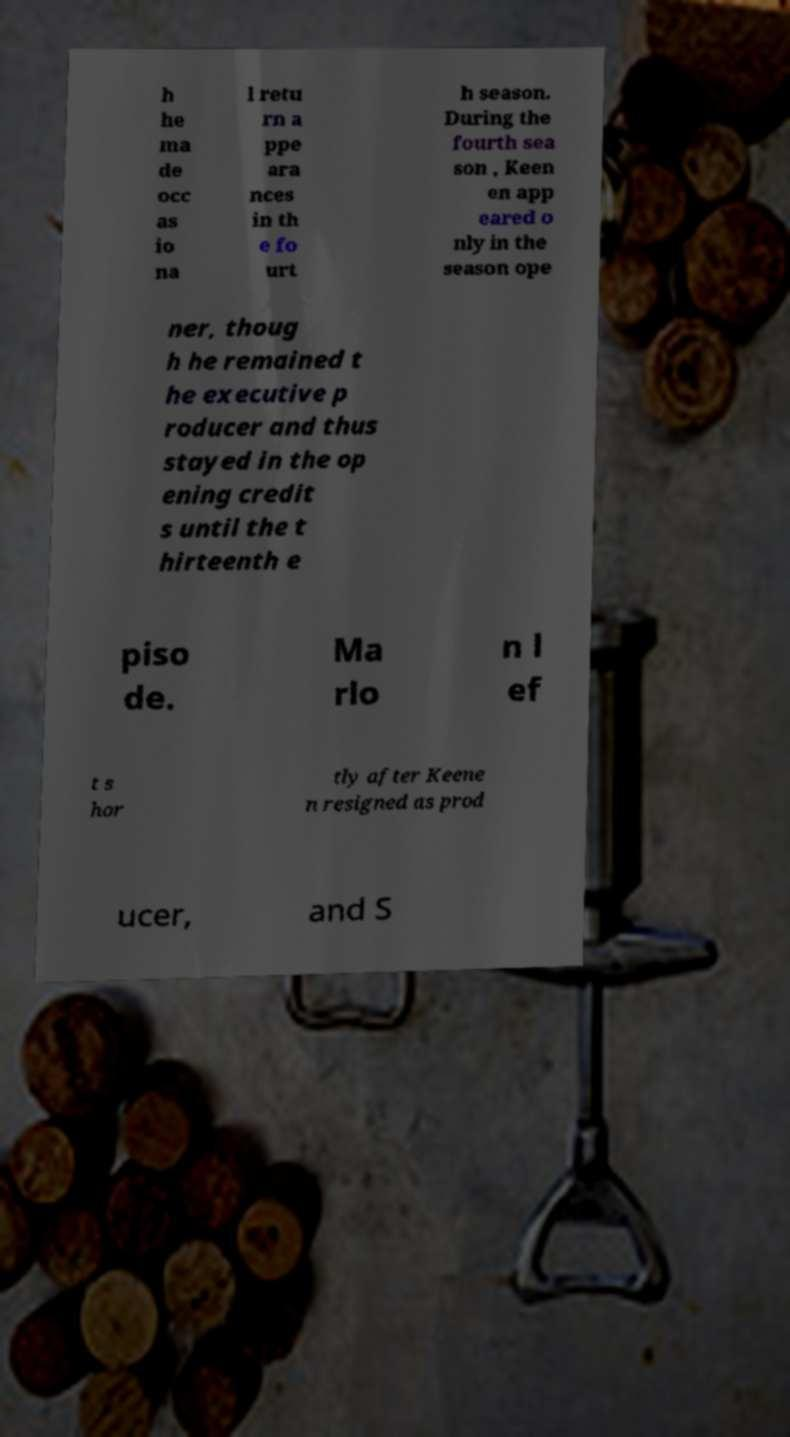I need the written content from this picture converted into text. Can you do that? h he ma de occ as io na l retu rn a ppe ara nces in th e fo urt h season. During the fourth sea son , Keen en app eared o nly in the season ope ner, thoug h he remained t he executive p roducer and thus stayed in the op ening credit s until the t hirteenth e piso de. Ma rlo n l ef t s hor tly after Keene n resigned as prod ucer, and S 